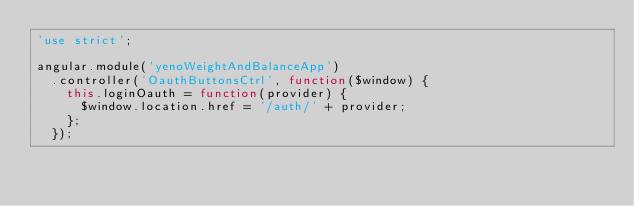Convert code to text. <code><loc_0><loc_0><loc_500><loc_500><_JavaScript_>'use strict';

angular.module('yenoWeightAndBalanceApp')
  .controller('OauthButtonsCtrl', function($window) {
    this.loginOauth = function(provider) {
      $window.location.href = '/auth/' + provider;
    };
  });
</code> 